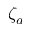Convert formula to latex. <formula><loc_0><loc_0><loc_500><loc_500>\zeta _ { a }</formula> 